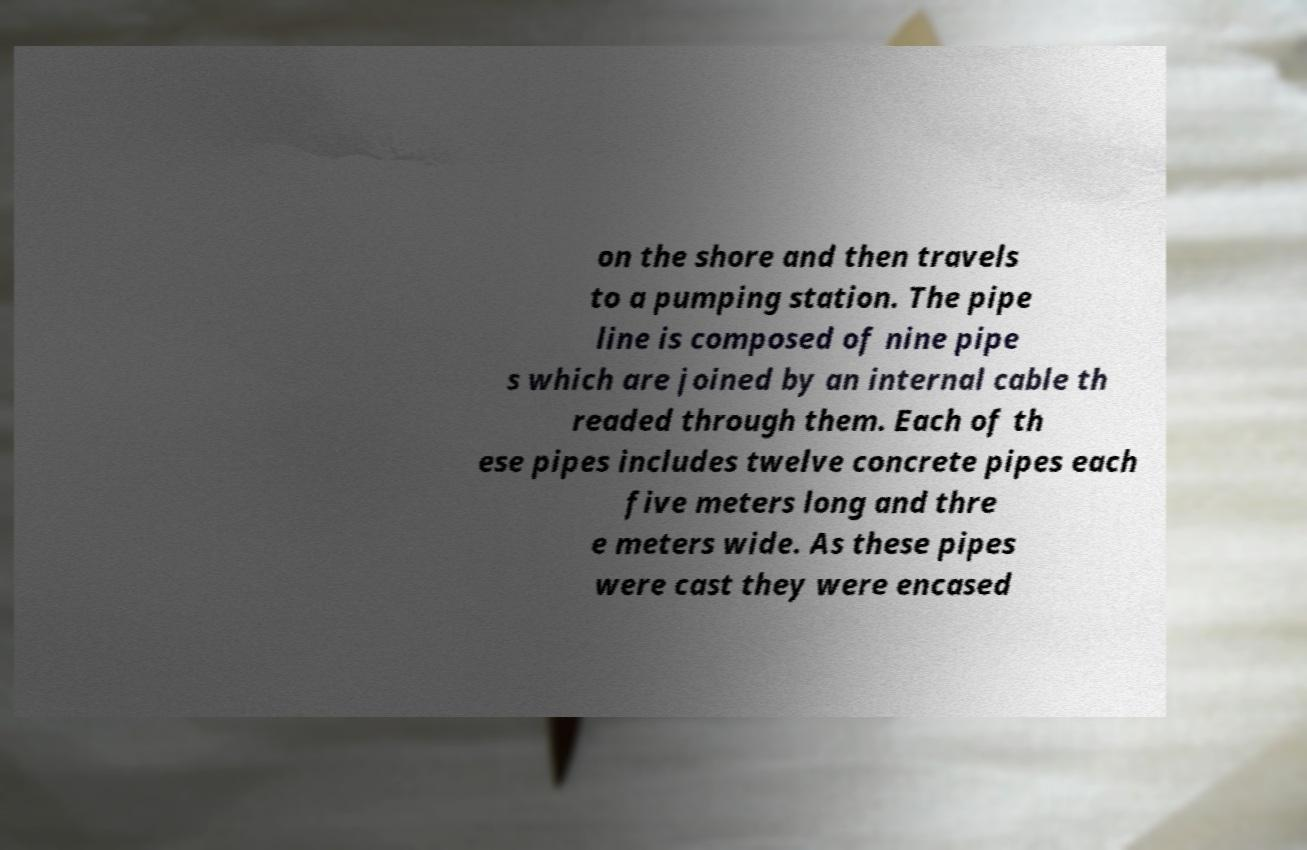Please identify and transcribe the text found in this image. on the shore and then travels to a pumping station. The pipe line is composed of nine pipe s which are joined by an internal cable th readed through them. Each of th ese pipes includes twelve concrete pipes each five meters long and thre e meters wide. As these pipes were cast they were encased 